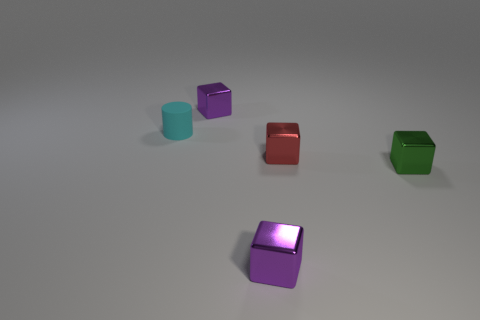Are there any other cylinders that have the same material as the tiny cyan cylinder?
Keep it short and to the point. No. Does the small cube that is behind the cyan cylinder have the same color as the tiny rubber cylinder?
Your response must be concise. No. The cyan object is what size?
Ensure brevity in your answer.  Small. Is there a small green object that is on the left side of the metallic thing in front of the small green metallic object in front of the small rubber thing?
Give a very brief answer. No. There is a small red metal block; what number of small purple cubes are in front of it?
Your answer should be very brief. 1. What number of things are either tiny cubes that are in front of the tiny cyan cylinder or purple metallic objects behind the red block?
Your answer should be compact. 4. Are there more cyan things than tiny things?
Your answer should be very brief. No. What is the color of the small metallic block in front of the small green metal cube?
Your response must be concise. Purple. Does the small cyan rubber object have the same shape as the red thing?
Ensure brevity in your answer.  No. There is a small object that is behind the red block and right of the small matte cylinder; what color is it?
Your answer should be compact. Purple. 